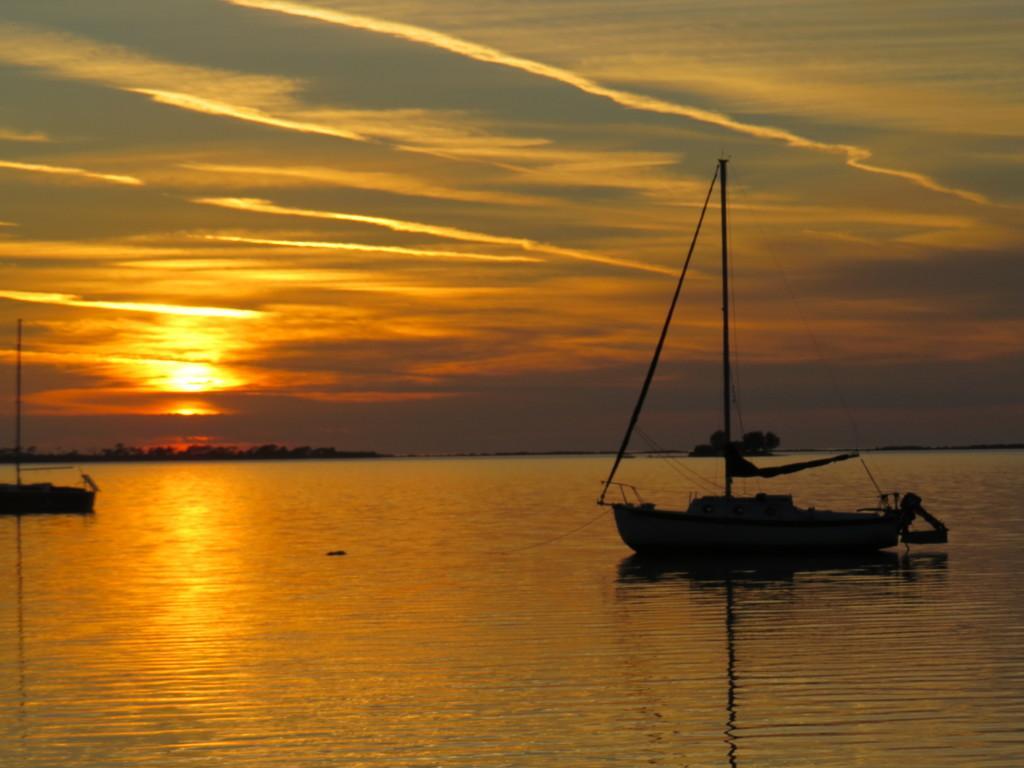Can you describe this image briefly? In this image we can see two boats in the water. In the background there are few trees. At the top we can see the sun in the sky. 